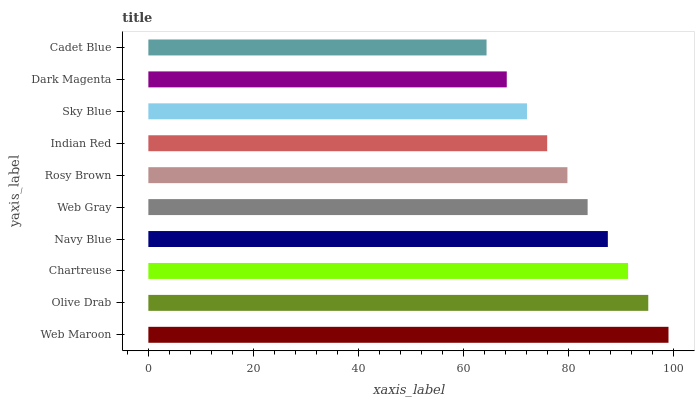Is Cadet Blue the minimum?
Answer yes or no. Yes. Is Web Maroon the maximum?
Answer yes or no. Yes. Is Olive Drab the minimum?
Answer yes or no. No. Is Olive Drab the maximum?
Answer yes or no. No. Is Web Maroon greater than Olive Drab?
Answer yes or no. Yes. Is Olive Drab less than Web Maroon?
Answer yes or no. Yes. Is Olive Drab greater than Web Maroon?
Answer yes or no. No. Is Web Maroon less than Olive Drab?
Answer yes or no. No. Is Web Gray the high median?
Answer yes or no. Yes. Is Rosy Brown the low median?
Answer yes or no. Yes. Is Dark Magenta the high median?
Answer yes or no. No. Is Web Maroon the low median?
Answer yes or no. No. 